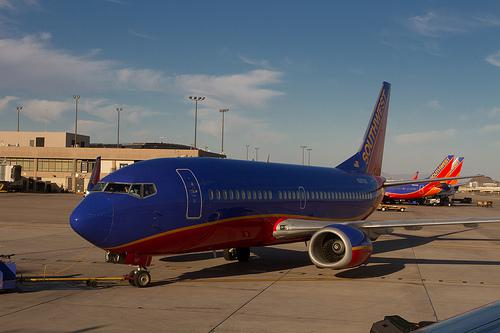Question: how many airplanes can be seen?
Choices:
A. Two.
B. Three.
C. One.
D. Five.
Answer with the letter. Answer: B Question: what is the picture of?
Choices:
A. A boat.
B. An airplane.
C. A train.
D. A truck.
Answer with the letter. Answer: B Question: where was the picture taken?
Choices:
A. A library.
B. A hotel.
C. Airport.
D. A train platform.
Answer with the letter. Answer: C 